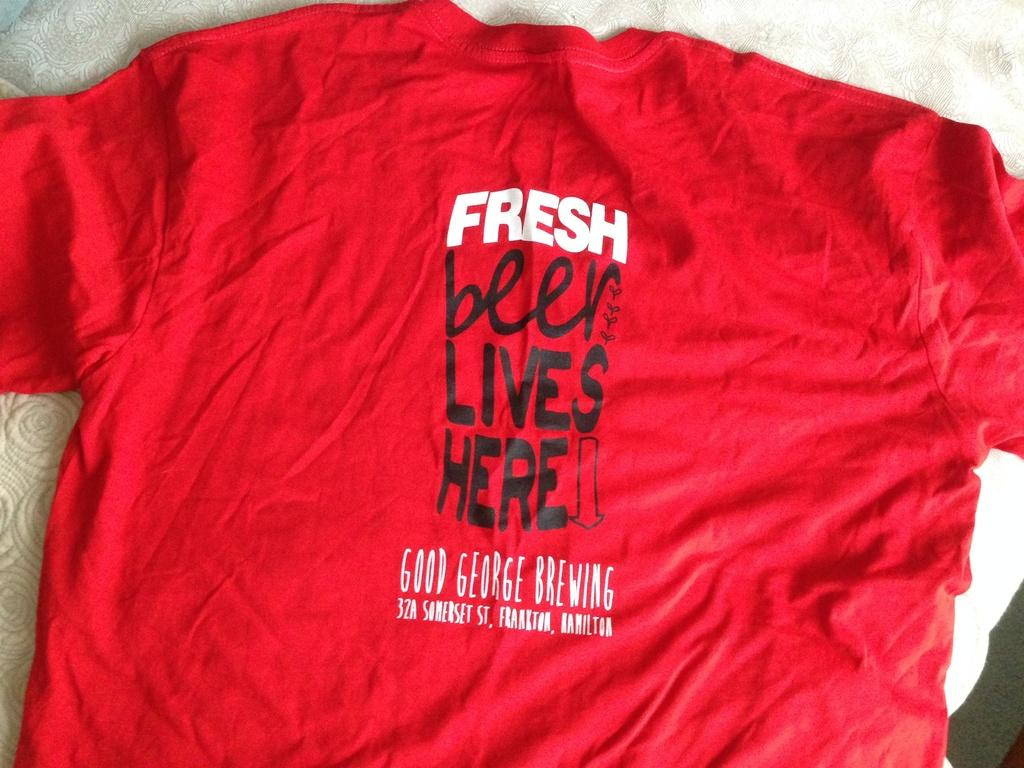<image>
Present a compact description of the photo's key features. A red t-shirt from Good George Brewing advertises fresh beer. 